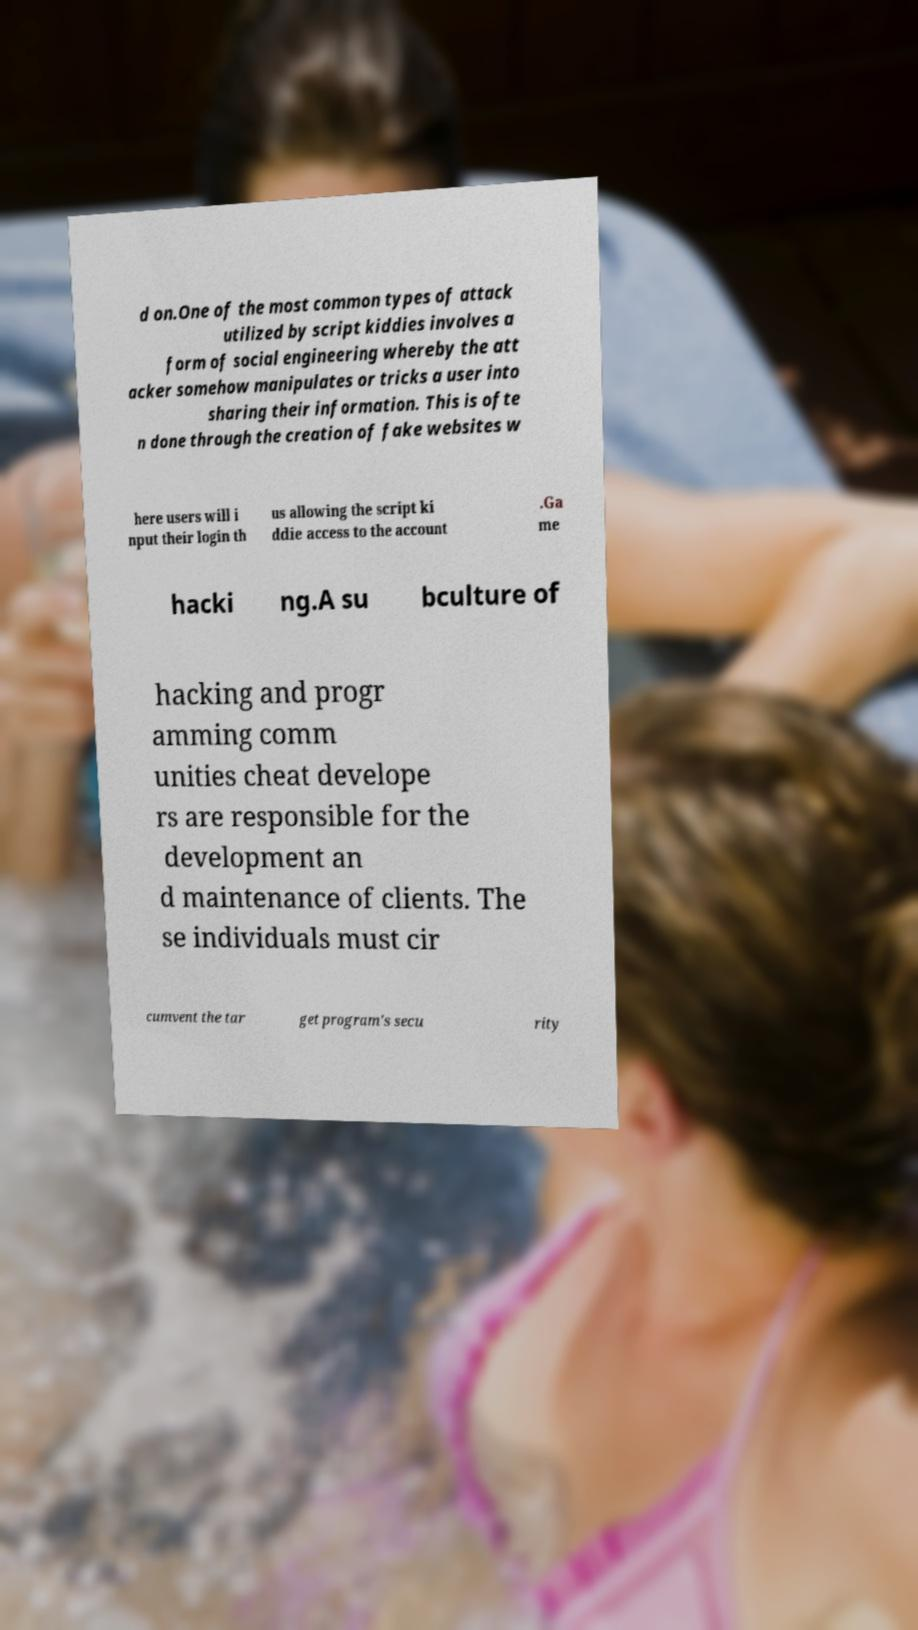I need the written content from this picture converted into text. Can you do that? d on.One of the most common types of attack utilized by script kiddies involves a form of social engineering whereby the att acker somehow manipulates or tricks a user into sharing their information. This is ofte n done through the creation of fake websites w here users will i nput their login th us allowing the script ki ddie access to the account .Ga me hacki ng.A su bculture of hacking and progr amming comm unities cheat develope rs are responsible for the development an d maintenance of clients. The se individuals must cir cumvent the tar get program's secu rity 